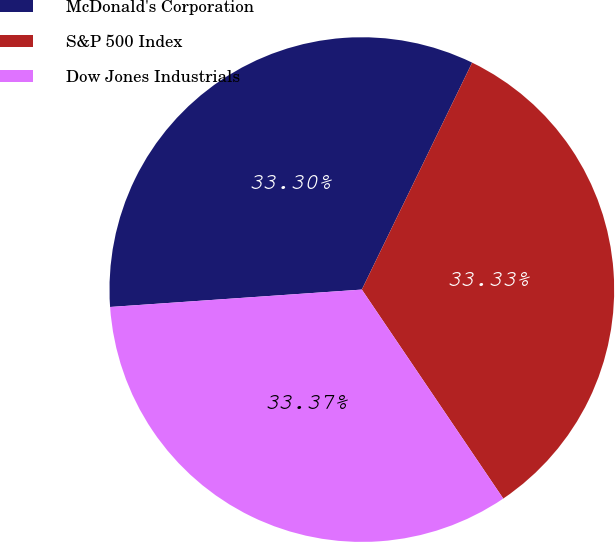<chart> <loc_0><loc_0><loc_500><loc_500><pie_chart><fcel>McDonald's Corporation<fcel>S&P 500 Index<fcel>Dow Jones Industrials<nl><fcel>33.3%<fcel>33.33%<fcel>33.37%<nl></chart> 